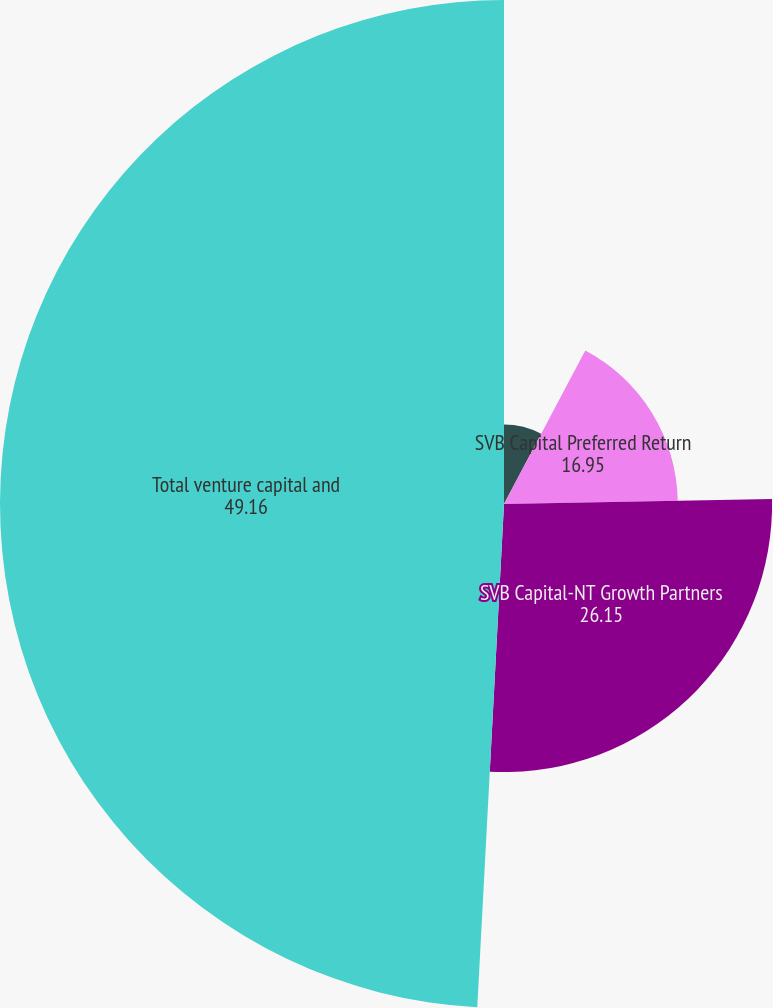<chart> <loc_0><loc_0><loc_500><loc_500><pie_chart><fcel>SVB Strategic Investors Fund<fcel>SVB Capital Preferred Return<fcel>SVB Capital-NT Growth Partners<fcel>Total venture capital and<nl><fcel>7.75%<fcel>16.95%<fcel>26.15%<fcel>49.16%<nl></chart> 